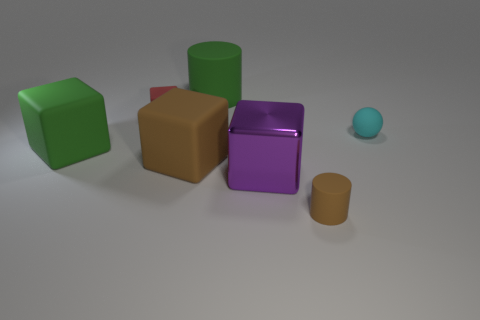Is there any other thing that has the same material as the purple thing?
Offer a very short reply. No. Are there more brown rubber things on the left side of the metallic object than small gray metallic cylinders?
Offer a terse response. Yes. There is a cylinder behind the big purple metal cube that is in front of the rubber cylinder to the left of the brown cylinder; what is its material?
Keep it short and to the point. Rubber. Are the big green cube and the small object right of the small cylinder made of the same material?
Offer a terse response. Yes. What is the material of the other big green object that is the same shape as the metal object?
Provide a short and direct response. Rubber. Are there more rubber things on the right side of the big metallic thing than big green matte objects that are in front of the green cube?
Ensure brevity in your answer.  Yes. There is a small brown object that is the same material as the small ball; what is its shape?
Offer a terse response. Cylinder. What number of other things are there of the same shape as the big brown object?
Your answer should be compact. 3. What shape is the green object that is right of the large brown object?
Provide a succinct answer. Cylinder. What color is the tiny cylinder?
Keep it short and to the point. Brown. 